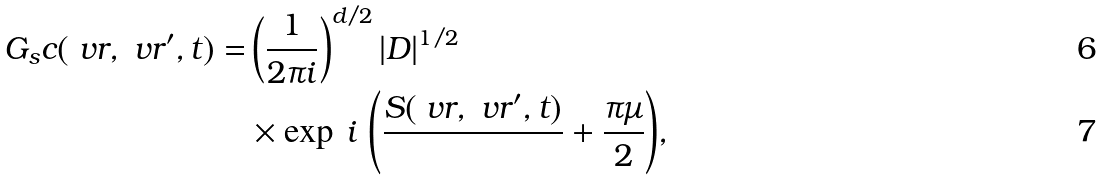Convert formula to latex. <formula><loc_0><loc_0><loc_500><loc_500>G _ { s } c ( \ v r , \ v r ^ { \prime } , t ) = & \left ( \frac { 1 } { 2 \pi i } \right ) ^ { d / 2 } | D | ^ { 1 / 2 } \\ & \times \exp { \, i \, \left ( \frac { S ( \ v r , \ v r ^ { \prime } , t ) } { } + \frac { \pi \mu } { 2 } \right ) } ,</formula> 